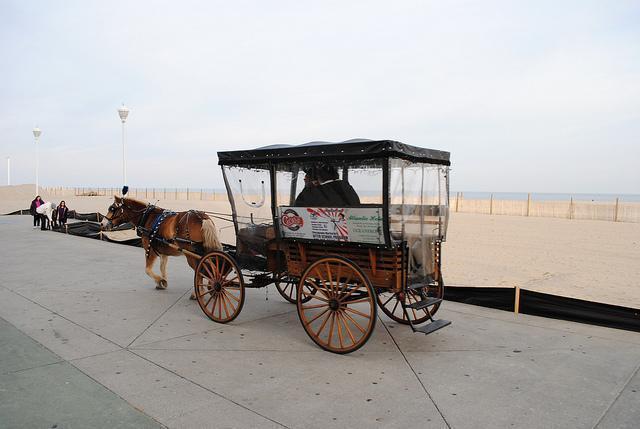What is near the sidewalk here?
Select the accurate answer and provide justification: `Answer: choice
Rationale: srationale.`
Options: Beach, grocery store, cow fields, dairy. Answer: beach.
Rationale: There is a lot of sand and then adjacent to it is a large body of water. 